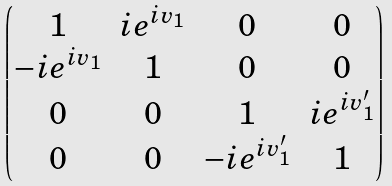<formula> <loc_0><loc_0><loc_500><loc_500>\begin{pmatrix} 1 & i e ^ { i v _ { 1 } } & 0 & 0 \\ - i e ^ { i v _ { 1 } } & 1 & 0 & 0 \\ 0 & 0 & 1 & i e ^ { i v _ { 1 } ^ { \prime } } \\ 0 & 0 & - i e ^ { i v _ { 1 } ^ { \prime } } & 1 \end{pmatrix}</formula> 